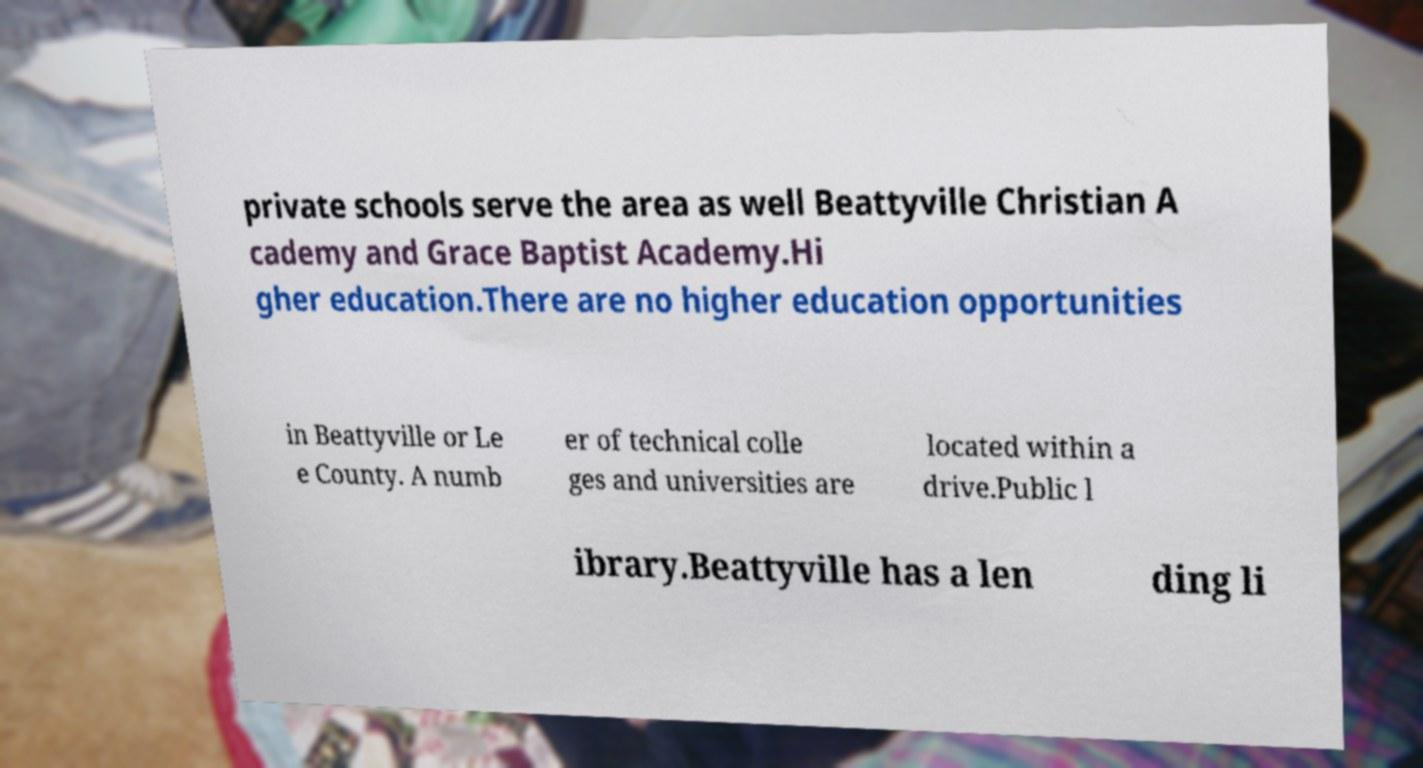I need the written content from this picture converted into text. Can you do that? private schools serve the area as well Beattyville Christian A cademy and Grace Baptist Academy.Hi gher education.There are no higher education opportunities in Beattyville or Le e County. A numb er of technical colle ges and universities are located within a drive.Public l ibrary.Beattyville has a len ding li 